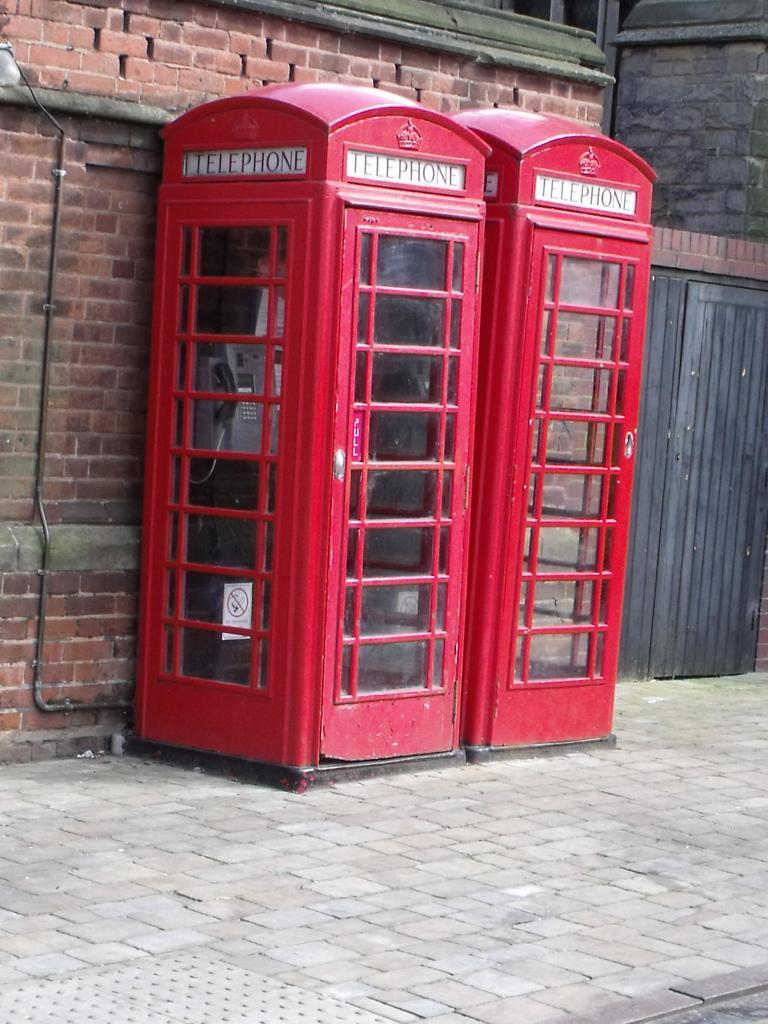Provide a one-sentence caption for the provided image. Two red phone booths that says "Telephone" on top. 